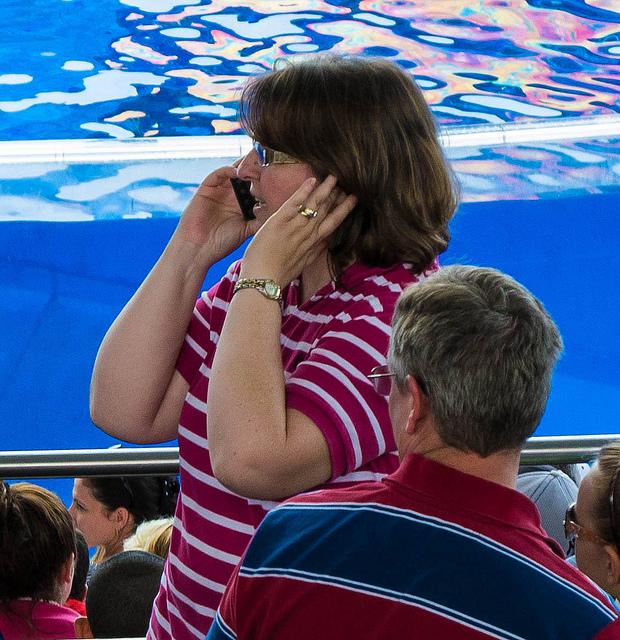Where is herring?
Write a very short answer. On her finger. What is behind the woman?
Keep it brief. Water. What is the woman doing?
Concise answer only. Talking on phone. 